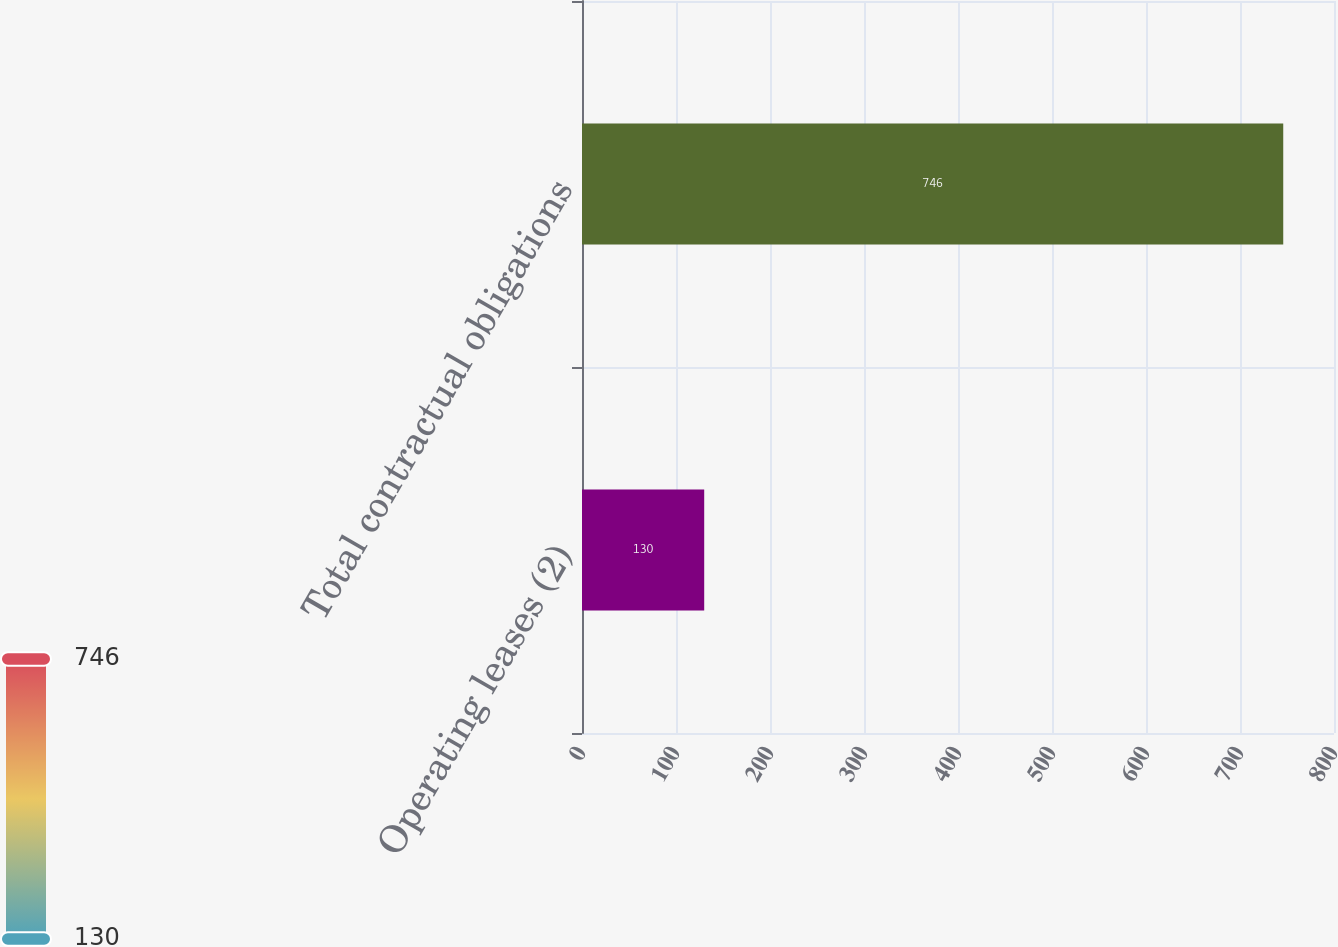Convert chart. <chart><loc_0><loc_0><loc_500><loc_500><bar_chart><fcel>Operating leases (2)<fcel>Total contractual obligations<nl><fcel>130<fcel>746<nl></chart> 